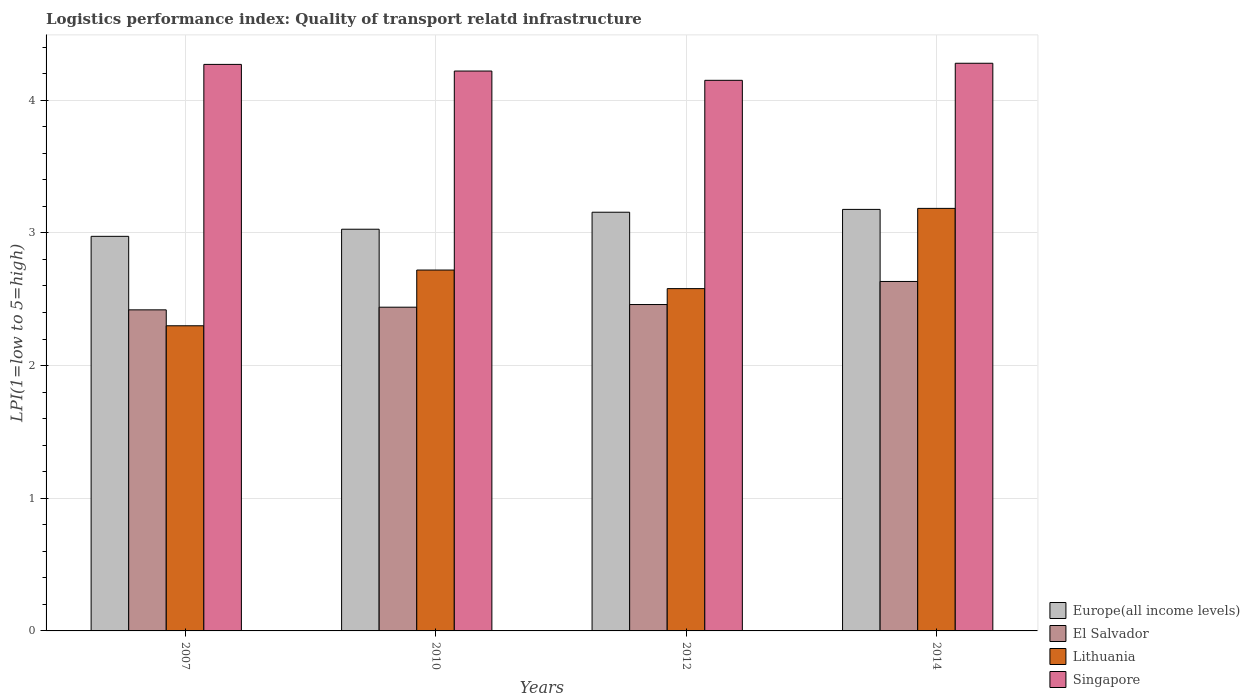How many different coloured bars are there?
Your answer should be compact. 4. How many groups of bars are there?
Provide a short and direct response. 4. In how many cases, is the number of bars for a given year not equal to the number of legend labels?
Keep it short and to the point. 0. What is the logistics performance index in Lithuania in 2007?
Keep it short and to the point. 2.3. Across all years, what is the maximum logistics performance index in Singapore?
Ensure brevity in your answer.  4.28. Across all years, what is the minimum logistics performance index in Lithuania?
Your response must be concise. 2.3. In which year was the logistics performance index in Europe(all income levels) maximum?
Keep it short and to the point. 2014. What is the total logistics performance index in Lithuania in the graph?
Your answer should be compact. 10.78. What is the difference between the logistics performance index in Lithuania in 2007 and that in 2012?
Offer a very short reply. -0.28. What is the difference between the logistics performance index in Europe(all income levels) in 2007 and the logistics performance index in Lithuania in 2010?
Offer a terse response. 0.25. What is the average logistics performance index in El Salvador per year?
Keep it short and to the point. 2.49. In the year 2007, what is the difference between the logistics performance index in Singapore and logistics performance index in Europe(all income levels)?
Your response must be concise. 1.3. In how many years, is the logistics performance index in Singapore greater than 0.2?
Your response must be concise. 4. What is the ratio of the logistics performance index in El Salvador in 2007 to that in 2010?
Give a very brief answer. 0.99. Is the logistics performance index in Europe(all income levels) in 2007 less than that in 2014?
Ensure brevity in your answer.  Yes. What is the difference between the highest and the second highest logistics performance index in Lithuania?
Keep it short and to the point. 0.46. What is the difference between the highest and the lowest logistics performance index in Lithuania?
Provide a succinct answer. 0.88. Is the sum of the logistics performance index in Singapore in 2010 and 2014 greater than the maximum logistics performance index in Europe(all income levels) across all years?
Give a very brief answer. Yes. Is it the case that in every year, the sum of the logistics performance index in Europe(all income levels) and logistics performance index in Singapore is greater than the sum of logistics performance index in El Salvador and logistics performance index in Lithuania?
Keep it short and to the point. Yes. What does the 4th bar from the left in 2007 represents?
Your answer should be compact. Singapore. What does the 3rd bar from the right in 2014 represents?
Give a very brief answer. El Salvador. Is it the case that in every year, the sum of the logistics performance index in El Salvador and logistics performance index in Lithuania is greater than the logistics performance index in Europe(all income levels)?
Ensure brevity in your answer.  Yes. How many bars are there?
Keep it short and to the point. 16. Are all the bars in the graph horizontal?
Your answer should be very brief. No. How many years are there in the graph?
Make the answer very short. 4. What is the difference between two consecutive major ticks on the Y-axis?
Ensure brevity in your answer.  1. Does the graph contain any zero values?
Your response must be concise. No. Where does the legend appear in the graph?
Make the answer very short. Bottom right. How are the legend labels stacked?
Provide a succinct answer. Vertical. What is the title of the graph?
Give a very brief answer. Logistics performance index: Quality of transport relatd infrastructure. Does "Sierra Leone" appear as one of the legend labels in the graph?
Offer a very short reply. No. What is the label or title of the X-axis?
Your response must be concise. Years. What is the label or title of the Y-axis?
Your answer should be very brief. LPI(1=low to 5=high). What is the LPI(1=low to 5=high) in Europe(all income levels) in 2007?
Offer a very short reply. 2.97. What is the LPI(1=low to 5=high) in El Salvador in 2007?
Your response must be concise. 2.42. What is the LPI(1=low to 5=high) of Lithuania in 2007?
Give a very brief answer. 2.3. What is the LPI(1=low to 5=high) in Singapore in 2007?
Provide a short and direct response. 4.27. What is the LPI(1=low to 5=high) of Europe(all income levels) in 2010?
Ensure brevity in your answer.  3.03. What is the LPI(1=low to 5=high) of El Salvador in 2010?
Ensure brevity in your answer.  2.44. What is the LPI(1=low to 5=high) in Lithuania in 2010?
Offer a very short reply. 2.72. What is the LPI(1=low to 5=high) of Singapore in 2010?
Give a very brief answer. 4.22. What is the LPI(1=low to 5=high) in Europe(all income levels) in 2012?
Give a very brief answer. 3.16. What is the LPI(1=low to 5=high) of El Salvador in 2012?
Provide a succinct answer. 2.46. What is the LPI(1=low to 5=high) of Lithuania in 2012?
Make the answer very short. 2.58. What is the LPI(1=low to 5=high) in Singapore in 2012?
Provide a short and direct response. 4.15. What is the LPI(1=low to 5=high) in Europe(all income levels) in 2014?
Keep it short and to the point. 3.18. What is the LPI(1=low to 5=high) in El Salvador in 2014?
Make the answer very short. 2.63. What is the LPI(1=low to 5=high) of Lithuania in 2014?
Offer a terse response. 3.18. What is the LPI(1=low to 5=high) of Singapore in 2014?
Your response must be concise. 4.28. Across all years, what is the maximum LPI(1=low to 5=high) in Europe(all income levels)?
Make the answer very short. 3.18. Across all years, what is the maximum LPI(1=low to 5=high) of El Salvador?
Your answer should be very brief. 2.63. Across all years, what is the maximum LPI(1=low to 5=high) in Lithuania?
Provide a short and direct response. 3.18. Across all years, what is the maximum LPI(1=low to 5=high) in Singapore?
Offer a very short reply. 4.28. Across all years, what is the minimum LPI(1=low to 5=high) in Europe(all income levels)?
Make the answer very short. 2.97. Across all years, what is the minimum LPI(1=low to 5=high) of El Salvador?
Offer a very short reply. 2.42. Across all years, what is the minimum LPI(1=low to 5=high) of Singapore?
Give a very brief answer. 4.15. What is the total LPI(1=low to 5=high) of Europe(all income levels) in the graph?
Your response must be concise. 12.33. What is the total LPI(1=low to 5=high) of El Salvador in the graph?
Offer a very short reply. 9.95. What is the total LPI(1=low to 5=high) of Lithuania in the graph?
Your answer should be very brief. 10.78. What is the total LPI(1=low to 5=high) in Singapore in the graph?
Provide a succinct answer. 16.92. What is the difference between the LPI(1=low to 5=high) of Europe(all income levels) in 2007 and that in 2010?
Offer a very short reply. -0.05. What is the difference between the LPI(1=low to 5=high) in El Salvador in 2007 and that in 2010?
Give a very brief answer. -0.02. What is the difference between the LPI(1=low to 5=high) of Lithuania in 2007 and that in 2010?
Ensure brevity in your answer.  -0.42. What is the difference between the LPI(1=low to 5=high) in Europe(all income levels) in 2007 and that in 2012?
Ensure brevity in your answer.  -0.18. What is the difference between the LPI(1=low to 5=high) of El Salvador in 2007 and that in 2012?
Your response must be concise. -0.04. What is the difference between the LPI(1=low to 5=high) of Lithuania in 2007 and that in 2012?
Provide a succinct answer. -0.28. What is the difference between the LPI(1=low to 5=high) in Singapore in 2007 and that in 2012?
Provide a short and direct response. 0.12. What is the difference between the LPI(1=low to 5=high) in Europe(all income levels) in 2007 and that in 2014?
Provide a short and direct response. -0.2. What is the difference between the LPI(1=low to 5=high) in El Salvador in 2007 and that in 2014?
Provide a short and direct response. -0.21. What is the difference between the LPI(1=low to 5=high) in Lithuania in 2007 and that in 2014?
Offer a very short reply. -0.88. What is the difference between the LPI(1=low to 5=high) in Singapore in 2007 and that in 2014?
Your answer should be very brief. -0.01. What is the difference between the LPI(1=low to 5=high) of Europe(all income levels) in 2010 and that in 2012?
Make the answer very short. -0.13. What is the difference between the LPI(1=low to 5=high) in El Salvador in 2010 and that in 2012?
Your response must be concise. -0.02. What is the difference between the LPI(1=low to 5=high) in Lithuania in 2010 and that in 2012?
Give a very brief answer. 0.14. What is the difference between the LPI(1=low to 5=high) in Singapore in 2010 and that in 2012?
Offer a terse response. 0.07. What is the difference between the LPI(1=low to 5=high) of Europe(all income levels) in 2010 and that in 2014?
Ensure brevity in your answer.  -0.15. What is the difference between the LPI(1=low to 5=high) in El Salvador in 2010 and that in 2014?
Make the answer very short. -0.19. What is the difference between the LPI(1=low to 5=high) of Lithuania in 2010 and that in 2014?
Ensure brevity in your answer.  -0.46. What is the difference between the LPI(1=low to 5=high) in Singapore in 2010 and that in 2014?
Ensure brevity in your answer.  -0.06. What is the difference between the LPI(1=low to 5=high) of Europe(all income levels) in 2012 and that in 2014?
Ensure brevity in your answer.  -0.02. What is the difference between the LPI(1=low to 5=high) in El Salvador in 2012 and that in 2014?
Provide a short and direct response. -0.17. What is the difference between the LPI(1=low to 5=high) of Lithuania in 2012 and that in 2014?
Ensure brevity in your answer.  -0.6. What is the difference between the LPI(1=low to 5=high) in Singapore in 2012 and that in 2014?
Give a very brief answer. -0.13. What is the difference between the LPI(1=low to 5=high) in Europe(all income levels) in 2007 and the LPI(1=low to 5=high) in El Salvador in 2010?
Offer a terse response. 0.53. What is the difference between the LPI(1=low to 5=high) in Europe(all income levels) in 2007 and the LPI(1=low to 5=high) in Lithuania in 2010?
Ensure brevity in your answer.  0.25. What is the difference between the LPI(1=low to 5=high) of Europe(all income levels) in 2007 and the LPI(1=low to 5=high) of Singapore in 2010?
Your response must be concise. -1.25. What is the difference between the LPI(1=low to 5=high) of Lithuania in 2007 and the LPI(1=low to 5=high) of Singapore in 2010?
Offer a very short reply. -1.92. What is the difference between the LPI(1=low to 5=high) in Europe(all income levels) in 2007 and the LPI(1=low to 5=high) in El Salvador in 2012?
Your response must be concise. 0.51. What is the difference between the LPI(1=low to 5=high) of Europe(all income levels) in 2007 and the LPI(1=low to 5=high) of Lithuania in 2012?
Your response must be concise. 0.39. What is the difference between the LPI(1=low to 5=high) in Europe(all income levels) in 2007 and the LPI(1=low to 5=high) in Singapore in 2012?
Offer a very short reply. -1.18. What is the difference between the LPI(1=low to 5=high) of El Salvador in 2007 and the LPI(1=low to 5=high) of Lithuania in 2012?
Offer a very short reply. -0.16. What is the difference between the LPI(1=low to 5=high) in El Salvador in 2007 and the LPI(1=low to 5=high) in Singapore in 2012?
Make the answer very short. -1.73. What is the difference between the LPI(1=low to 5=high) of Lithuania in 2007 and the LPI(1=low to 5=high) of Singapore in 2012?
Keep it short and to the point. -1.85. What is the difference between the LPI(1=low to 5=high) in Europe(all income levels) in 2007 and the LPI(1=low to 5=high) in El Salvador in 2014?
Your answer should be compact. 0.34. What is the difference between the LPI(1=low to 5=high) of Europe(all income levels) in 2007 and the LPI(1=low to 5=high) of Lithuania in 2014?
Make the answer very short. -0.21. What is the difference between the LPI(1=low to 5=high) in Europe(all income levels) in 2007 and the LPI(1=low to 5=high) in Singapore in 2014?
Provide a succinct answer. -1.3. What is the difference between the LPI(1=low to 5=high) in El Salvador in 2007 and the LPI(1=low to 5=high) in Lithuania in 2014?
Provide a short and direct response. -0.76. What is the difference between the LPI(1=low to 5=high) of El Salvador in 2007 and the LPI(1=low to 5=high) of Singapore in 2014?
Keep it short and to the point. -1.86. What is the difference between the LPI(1=low to 5=high) in Lithuania in 2007 and the LPI(1=low to 5=high) in Singapore in 2014?
Offer a very short reply. -1.98. What is the difference between the LPI(1=low to 5=high) in Europe(all income levels) in 2010 and the LPI(1=low to 5=high) in El Salvador in 2012?
Ensure brevity in your answer.  0.57. What is the difference between the LPI(1=low to 5=high) of Europe(all income levels) in 2010 and the LPI(1=low to 5=high) of Lithuania in 2012?
Make the answer very short. 0.45. What is the difference between the LPI(1=low to 5=high) of Europe(all income levels) in 2010 and the LPI(1=low to 5=high) of Singapore in 2012?
Ensure brevity in your answer.  -1.12. What is the difference between the LPI(1=low to 5=high) of El Salvador in 2010 and the LPI(1=low to 5=high) of Lithuania in 2012?
Provide a short and direct response. -0.14. What is the difference between the LPI(1=low to 5=high) in El Salvador in 2010 and the LPI(1=low to 5=high) in Singapore in 2012?
Offer a terse response. -1.71. What is the difference between the LPI(1=low to 5=high) of Lithuania in 2010 and the LPI(1=low to 5=high) of Singapore in 2012?
Ensure brevity in your answer.  -1.43. What is the difference between the LPI(1=low to 5=high) in Europe(all income levels) in 2010 and the LPI(1=low to 5=high) in El Salvador in 2014?
Offer a very short reply. 0.39. What is the difference between the LPI(1=low to 5=high) in Europe(all income levels) in 2010 and the LPI(1=low to 5=high) in Lithuania in 2014?
Keep it short and to the point. -0.16. What is the difference between the LPI(1=low to 5=high) of Europe(all income levels) in 2010 and the LPI(1=low to 5=high) of Singapore in 2014?
Provide a short and direct response. -1.25. What is the difference between the LPI(1=low to 5=high) in El Salvador in 2010 and the LPI(1=low to 5=high) in Lithuania in 2014?
Provide a succinct answer. -0.74. What is the difference between the LPI(1=low to 5=high) of El Salvador in 2010 and the LPI(1=low to 5=high) of Singapore in 2014?
Your response must be concise. -1.84. What is the difference between the LPI(1=low to 5=high) of Lithuania in 2010 and the LPI(1=low to 5=high) of Singapore in 2014?
Your answer should be very brief. -1.56. What is the difference between the LPI(1=low to 5=high) in Europe(all income levels) in 2012 and the LPI(1=low to 5=high) in El Salvador in 2014?
Offer a very short reply. 0.52. What is the difference between the LPI(1=low to 5=high) in Europe(all income levels) in 2012 and the LPI(1=low to 5=high) in Lithuania in 2014?
Ensure brevity in your answer.  -0.03. What is the difference between the LPI(1=low to 5=high) in Europe(all income levels) in 2012 and the LPI(1=low to 5=high) in Singapore in 2014?
Your response must be concise. -1.12. What is the difference between the LPI(1=low to 5=high) in El Salvador in 2012 and the LPI(1=low to 5=high) in Lithuania in 2014?
Offer a very short reply. -0.72. What is the difference between the LPI(1=low to 5=high) of El Salvador in 2012 and the LPI(1=low to 5=high) of Singapore in 2014?
Offer a terse response. -1.82. What is the difference between the LPI(1=low to 5=high) of Lithuania in 2012 and the LPI(1=low to 5=high) of Singapore in 2014?
Keep it short and to the point. -1.7. What is the average LPI(1=low to 5=high) of Europe(all income levels) per year?
Offer a very short reply. 3.08. What is the average LPI(1=low to 5=high) in El Salvador per year?
Offer a terse response. 2.49. What is the average LPI(1=low to 5=high) of Lithuania per year?
Offer a terse response. 2.7. What is the average LPI(1=low to 5=high) of Singapore per year?
Offer a terse response. 4.23. In the year 2007, what is the difference between the LPI(1=low to 5=high) of Europe(all income levels) and LPI(1=low to 5=high) of El Salvador?
Your answer should be compact. 0.55. In the year 2007, what is the difference between the LPI(1=low to 5=high) of Europe(all income levels) and LPI(1=low to 5=high) of Lithuania?
Provide a short and direct response. 0.67. In the year 2007, what is the difference between the LPI(1=low to 5=high) in Europe(all income levels) and LPI(1=low to 5=high) in Singapore?
Offer a very short reply. -1.3. In the year 2007, what is the difference between the LPI(1=low to 5=high) of El Salvador and LPI(1=low to 5=high) of Lithuania?
Give a very brief answer. 0.12. In the year 2007, what is the difference between the LPI(1=low to 5=high) in El Salvador and LPI(1=low to 5=high) in Singapore?
Provide a short and direct response. -1.85. In the year 2007, what is the difference between the LPI(1=low to 5=high) of Lithuania and LPI(1=low to 5=high) of Singapore?
Your answer should be very brief. -1.97. In the year 2010, what is the difference between the LPI(1=low to 5=high) in Europe(all income levels) and LPI(1=low to 5=high) in El Salvador?
Keep it short and to the point. 0.59. In the year 2010, what is the difference between the LPI(1=low to 5=high) of Europe(all income levels) and LPI(1=low to 5=high) of Lithuania?
Offer a terse response. 0.31. In the year 2010, what is the difference between the LPI(1=low to 5=high) in Europe(all income levels) and LPI(1=low to 5=high) in Singapore?
Offer a very short reply. -1.19. In the year 2010, what is the difference between the LPI(1=low to 5=high) of El Salvador and LPI(1=low to 5=high) of Lithuania?
Provide a succinct answer. -0.28. In the year 2010, what is the difference between the LPI(1=low to 5=high) of El Salvador and LPI(1=low to 5=high) of Singapore?
Provide a short and direct response. -1.78. In the year 2012, what is the difference between the LPI(1=low to 5=high) in Europe(all income levels) and LPI(1=low to 5=high) in El Salvador?
Offer a terse response. 0.7. In the year 2012, what is the difference between the LPI(1=low to 5=high) in Europe(all income levels) and LPI(1=low to 5=high) in Lithuania?
Your answer should be very brief. 0.58. In the year 2012, what is the difference between the LPI(1=low to 5=high) in Europe(all income levels) and LPI(1=low to 5=high) in Singapore?
Make the answer very short. -0.99. In the year 2012, what is the difference between the LPI(1=low to 5=high) of El Salvador and LPI(1=low to 5=high) of Lithuania?
Provide a succinct answer. -0.12. In the year 2012, what is the difference between the LPI(1=low to 5=high) in El Salvador and LPI(1=low to 5=high) in Singapore?
Provide a short and direct response. -1.69. In the year 2012, what is the difference between the LPI(1=low to 5=high) of Lithuania and LPI(1=low to 5=high) of Singapore?
Ensure brevity in your answer.  -1.57. In the year 2014, what is the difference between the LPI(1=low to 5=high) in Europe(all income levels) and LPI(1=low to 5=high) in El Salvador?
Your response must be concise. 0.54. In the year 2014, what is the difference between the LPI(1=low to 5=high) of Europe(all income levels) and LPI(1=low to 5=high) of Lithuania?
Offer a terse response. -0.01. In the year 2014, what is the difference between the LPI(1=low to 5=high) in Europe(all income levels) and LPI(1=low to 5=high) in Singapore?
Offer a terse response. -1.1. In the year 2014, what is the difference between the LPI(1=low to 5=high) in El Salvador and LPI(1=low to 5=high) in Lithuania?
Your answer should be compact. -0.55. In the year 2014, what is the difference between the LPI(1=low to 5=high) in El Salvador and LPI(1=low to 5=high) in Singapore?
Offer a very short reply. -1.64. In the year 2014, what is the difference between the LPI(1=low to 5=high) of Lithuania and LPI(1=low to 5=high) of Singapore?
Make the answer very short. -1.09. What is the ratio of the LPI(1=low to 5=high) in Europe(all income levels) in 2007 to that in 2010?
Make the answer very short. 0.98. What is the ratio of the LPI(1=low to 5=high) in El Salvador in 2007 to that in 2010?
Keep it short and to the point. 0.99. What is the ratio of the LPI(1=low to 5=high) of Lithuania in 2007 to that in 2010?
Offer a very short reply. 0.85. What is the ratio of the LPI(1=low to 5=high) of Singapore in 2007 to that in 2010?
Ensure brevity in your answer.  1.01. What is the ratio of the LPI(1=low to 5=high) in Europe(all income levels) in 2007 to that in 2012?
Give a very brief answer. 0.94. What is the ratio of the LPI(1=low to 5=high) in El Salvador in 2007 to that in 2012?
Ensure brevity in your answer.  0.98. What is the ratio of the LPI(1=low to 5=high) of Lithuania in 2007 to that in 2012?
Provide a succinct answer. 0.89. What is the ratio of the LPI(1=low to 5=high) in Singapore in 2007 to that in 2012?
Give a very brief answer. 1.03. What is the ratio of the LPI(1=low to 5=high) of Europe(all income levels) in 2007 to that in 2014?
Your response must be concise. 0.94. What is the ratio of the LPI(1=low to 5=high) of El Salvador in 2007 to that in 2014?
Your answer should be very brief. 0.92. What is the ratio of the LPI(1=low to 5=high) of Lithuania in 2007 to that in 2014?
Give a very brief answer. 0.72. What is the ratio of the LPI(1=low to 5=high) of Singapore in 2007 to that in 2014?
Offer a very short reply. 1. What is the ratio of the LPI(1=low to 5=high) in Europe(all income levels) in 2010 to that in 2012?
Offer a very short reply. 0.96. What is the ratio of the LPI(1=low to 5=high) of Lithuania in 2010 to that in 2012?
Your response must be concise. 1.05. What is the ratio of the LPI(1=low to 5=high) in Singapore in 2010 to that in 2012?
Make the answer very short. 1.02. What is the ratio of the LPI(1=low to 5=high) of Europe(all income levels) in 2010 to that in 2014?
Your response must be concise. 0.95. What is the ratio of the LPI(1=low to 5=high) in El Salvador in 2010 to that in 2014?
Keep it short and to the point. 0.93. What is the ratio of the LPI(1=low to 5=high) in Lithuania in 2010 to that in 2014?
Offer a terse response. 0.85. What is the ratio of the LPI(1=low to 5=high) of Singapore in 2010 to that in 2014?
Your response must be concise. 0.99. What is the ratio of the LPI(1=low to 5=high) of El Salvador in 2012 to that in 2014?
Ensure brevity in your answer.  0.93. What is the ratio of the LPI(1=low to 5=high) in Lithuania in 2012 to that in 2014?
Keep it short and to the point. 0.81. What is the ratio of the LPI(1=low to 5=high) in Singapore in 2012 to that in 2014?
Offer a very short reply. 0.97. What is the difference between the highest and the second highest LPI(1=low to 5=high) of Europe(all income levels)?
Make the answer very short. 0.02. What is the difference between the highest and the second highest LPI(1=low to 5=high) of El Salvador?
Your response must be concise. 0.17. What is the difference between the highest and the second highest LPI(1=low to 5=high) of Lithuania?
Give a very brief answer. 0.46. What is the difference between the highest and the second highest LPI(1=low to 5=high) in Singapore?
Provide a short and direct response. 0.01. What is the difference between the highest and the lowest LPI(1=low to 5=high) in Europe(all income levels)?
Ensure brevity in your answer.  0.2. What is the difference between the highest and the lowest LPI(1=low to 5=high) in El Salvador?
Your response must be concise. 0.21. What is the difference between the highest and the lowest LPI(1=low to 5=high) in Lithuania?
Give a very brief answer. 0.88. What is the difference between the highest and the lowest LPI(1=low to 5=high) in Singapore?
Your response must be concise. 0.13. 